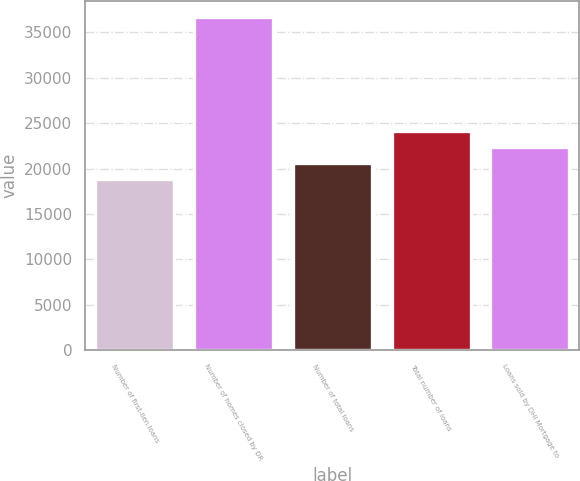<chart> <loc_0><loc_0><loc_500><loc_500><bar_chart><fcel>Number of first-lien loans<fcel>Number of homes closed by DR<fcel>Number of total loans<fcel>Total number of loans<fcel>Loans sold by DHI Mortgage to<nl><fcel>18821<fcel>36648<fcel>20603.7<fcel>24169.1<fcel>22386.4<nl></chart> 